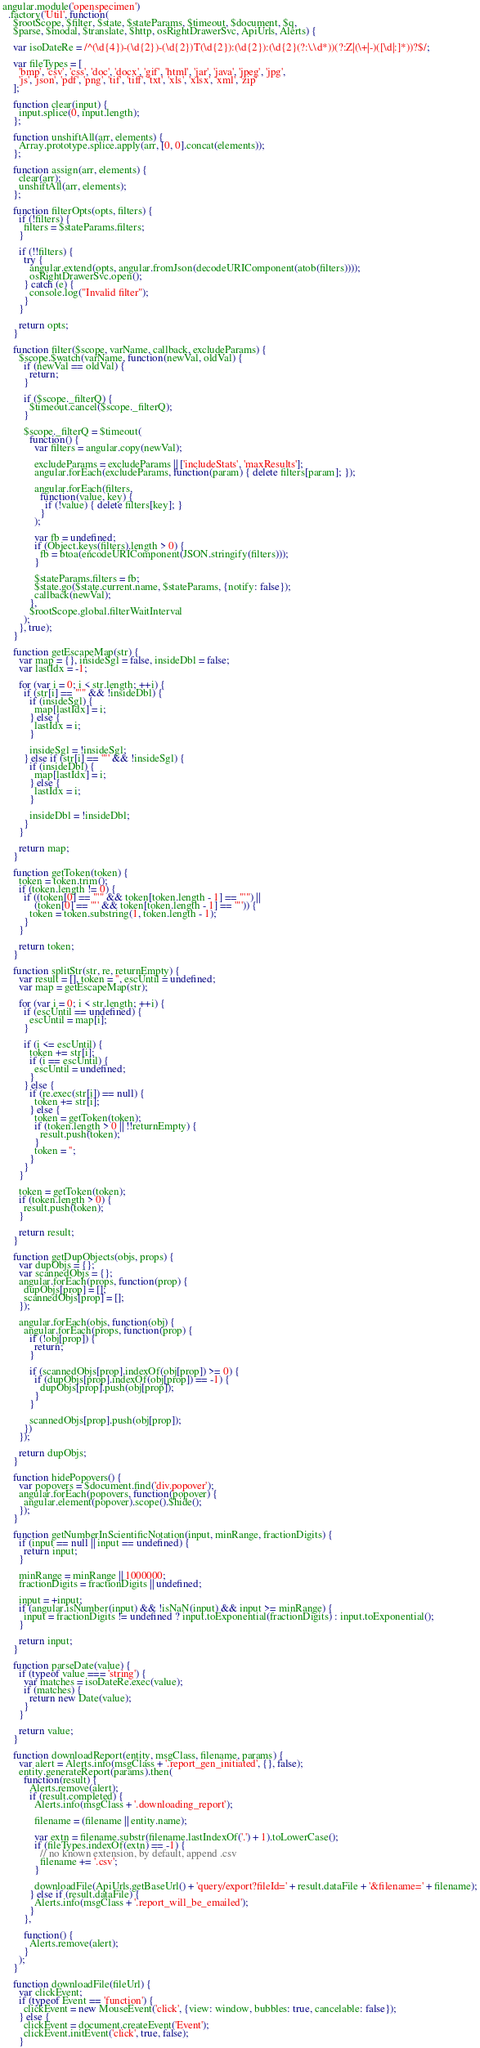Convert code to text. <code><loc_0><loc_0><loc_500><loc_500><_JavaScript_>
angular.module('openspecimen')
  .factory('Util', function(
    $rootScope, $filter, $state, $stateParams, $timeout, $document, $q,
    $parse, $modal, $translate, $http, osRightDrawerSvc, ApiUrls, Alerts) {

    var isoDateRe = /^(\d{4})-(\d{2})-(\d{2})T(\d{2}):(\d{2}):(\d{2}(?:\.\d*))(?:Z|(\+|-)([\d|:]*))?$/;

    var fileTypes = [
      'bmp', 'csv', 'css', 'doc', 'docx', 'gif', 'html', 'jar', 'java', 'jpeg', 'jpg',
      'js', 'json', 'pdf', 'png', 'tif', 'tiff', 'txt', 'xls', 'xlsx', 'xml', 'zip'
    ];

    function clear(input) {
      input.splice(0, input.length);
    };

    function unshiftAll(arr, elements) {
      Array.prototype.splice.apply(arr, [0, 0].concat(elements));
    };

    function assign(arr, elements) {
      clear(arr);
      unshiftAll(arr, elements);
    };

    function filterOpts(opts, filters) {
      if (!filters) {
        filters = $stateParams.filters;
      }

      if (!!filters) {
        try {
          angular.extend(opts, angular.fromJson(decodeURIComponent(atob(filters))));
          osRightDrawerSvc.open();
        } catch (e) {
          console.log("Invalid filter");
        }
      }

      return opts;
    }

    function filter($scope, varName, callback, excludeParams) {
      $scope.$watch(varName, function(newVal, oldVal) {
        if (newVal == oldVal) {
          return;
        }

        if ($scope._filterQ) {
          $timeout.cancel($scope._filterQ);
        }

        $scope._filterQ = $timeout(
          function() {
            var filters = angular.copy(newVal);

            excludeParams = excludeParams || ['includeStats', 'maxResults'];
            angular.forEach(excludeParams, function(param) { delete filters[param]; });

            angular.forEach(filters,
              function(value, key) {
                if (!value) { delete filters[key]; }
              }
            );

            var fb = undefined;
            if (Object.keys(filters).length > 0) {
              fb = btoa(encodeURIComponent(JSON.stringify(filters)));
            }

            $stateParams.filters = fb;
            $state.go($state.current.name, $stateParams, {notify: false});
            callback(newVal);
          },
          $rootScope.global.filterWaitInterval
        );
      }, true);
    }

    function getEscapeMap(str) {
      var map = {}, insideSgl = false, insideDbl = false;
      var lastIdx = -1;

      for (var i = 0; i < str.length; ++i) {
        if (str[i] == "'" && !insideDbl) {
          if (insideSgl) {
            map[lastIdx] = i;
          } else {
            lastIdx = i;
          }

          insideSgl = !insideSgl;
        } else if (str[i] == '"' && !insideSgl) {
          if (insideDbl) {
            map[lastIdx] = i;
          } else {
            lastIdx = i;
          }

          insideDbl = !insideDbl;
        }
      }

      return map;
    }

    function getToken(token) {
      token = token.trim();
      if (token.length != 0) {
        if ((token[0] == "'" && token[token.length - 1] == "'") ||
            (token[0] == '"' && token[token.length - 1] == '"')) {
          token = token.substring(1, token.length - 1);
        }
      }

      return token;
    }

    function splitStr(str, re, returnEmpty) {
      var result = [], token = '', escUntil = undefined;
      var map = getEscapeMap(str);

      for (var i = 0; i < str.length; ++i) {
        if (escUntil == undefined) {
          escUntil = map[i];
        }

        if (i <= escUntil) {
          token += str[i];
          if (i == escUntil) {
            escUntil = undefined;
          }
        } else {
          if (re.exec(str[i]) == null) {
            token += str[i];
          } else {
            token = getToken(token);
            if (token.length > 0 || !!returnEmpty) {
              result.push(token);
            }
            token = '';
          }
        }
      }

      token = getToken(token);
      if (token.length > 0) {
        result.push(token);
      }

      return result;
    }

    function getDupObjects(objs, props) {
      var dupObjs = {};
      var scannedObjs = {};
      angular.forEach(props, function(prop) {
        dupObjs[prop] = [];
        scannedObjs[prop] = [];
      });

      angular.forEach(objs, function(obj) {
        angular.forEach(props, function(prop) {
          if (!obj[prop]) {
            return;
          }

          if (scannedObjs[prop].indexOf(obj[prop]) >= 0) {
            if (dupObjs[prop].indexOf(obj[prop]) == -1) {
              dupObjs[prop].push(obj[prop]);
            }
          }

          scannedObjs[prop].push(obj[prop]);
        })
      });
 
      return dupObjs;
    }

    function hidePopovers() {
      var popovers = $document.find('div.popover');
      angular.forEach(popovers, function(popover) {
        angular.element(popover).scope().$hide();
      });
    }

    function getNumberInScientificNotation(input, minRange, fractionDigits) {
      if (input == null || input == undefined) {
        return input;
      }

      minRange = minRange || 1000000;
      fractionDigits = fractionDigits || undefined;
      
      input = +input;
      if (angular.isNumber(input) && !isNaN(input) && input >= minRange) {
        input = fractionDigits != undefined ? input.toExponential(fractionDigits) : input.toExponential();
      }

      return input;
    }

    function parseDate(value) {
      if (typeof value === 'string') {
        var matches = isoDateRe.exec(value);
        if (matches) {
          return new Date(value);
        }
      }

      return value;
    }

    function downloadReport(entity, msgClass, filename, params) {
      var alert = Alerts.info(msgClass + '.report_gen_initiated', {}, false);
      entity.generateReport(params).then(
        function(result) {
          Alerts.remove(alert);
          if (result.completed) {
            Alerts.info(msgClass + '.downloading_report');

            filename = (filename || entity.name);

            var extn = filename.substr(filename.lastIndexOf('.') + 1).toLowerCase();
            if (fileTypes.indexOf(extn) == -1) {
              // no known extension, by default, append .csv
              filename += '.csv';
            }

            downloadFile(ApiUrls.getBaseUrl() + 'query/export?fileId=' + result.dataFile + '&filename=' + filename);
          } else if (result.dataFile) {
            Alerts.info(msgClass + '.report_will_be_emailed');
          }
        },

        function() {
          Alerts.remove(alert);
        }
      );
    }

    function downloadFile(fileUrl) {
      var clickEvent;
      if (typeof Event == 'function') {
        clickEvent = new MouseEvent('click', {view: window, bubbles: true, cancelable: false});
      } else {
        clickEvent = document.createEvent('Event');
        clickEvent.initEvent('click', true, false);
      }
</code> 